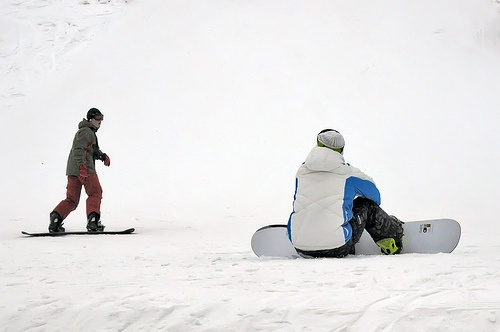Describe the objects in this image and their specific colors. I can see people in lightgray, black, darkgray, and blue tones, people in lightgray, black, maroon, gray, and white tones, snowboard in lightgray, darkgray, and gray tones, and snowboard in lightgray, black, gray, and darkgray tones in this image. 